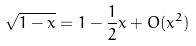Convert formula to latex. <formula><loc_0><loc_0><loc_500><loc_500>\sqrt { 1 - x } = 1 - \frac { 1 } { 2 } x + O ( x ^ { 2 } )</formula> 